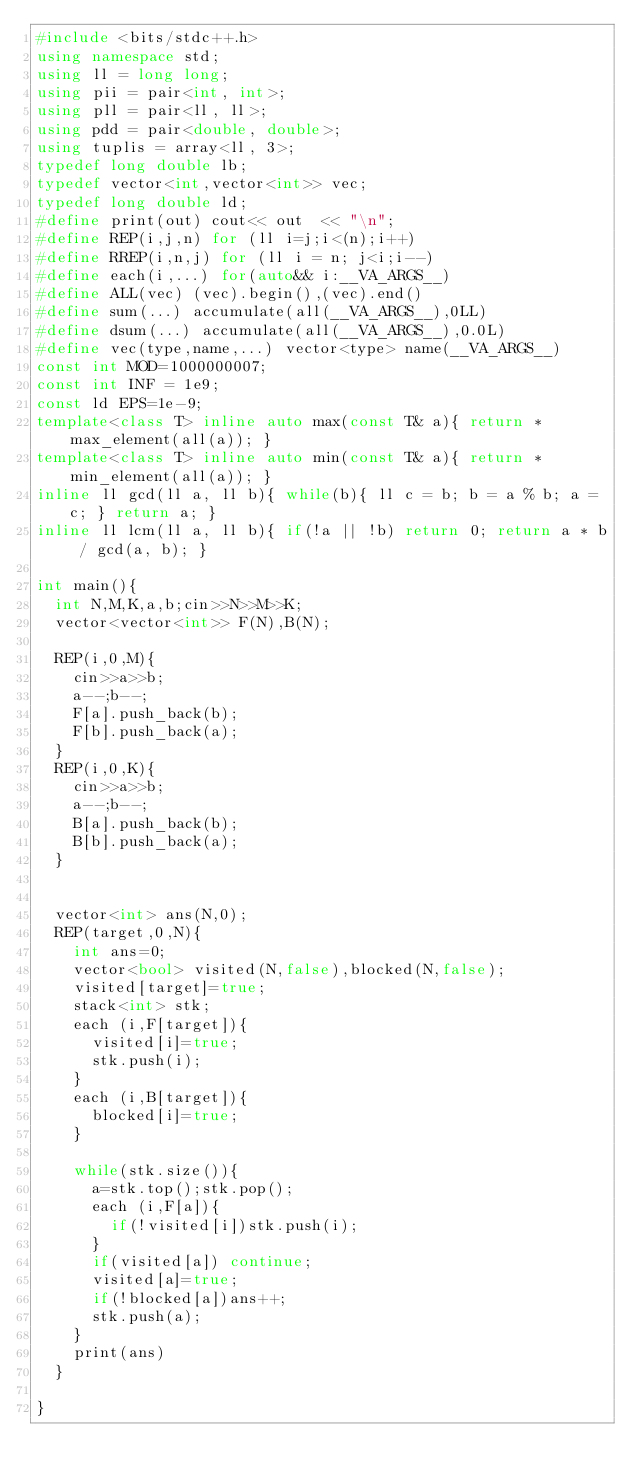<code> <loc_0><loc_0><loc_500><loc_500><_C++_>#include <bits/stdc++.h>
using namespace std;
using ll = long long;
using pii = pair<int, int>;
using pll = pair<ll, ll>;
using pdd = pair<double, double>;
using tuplis = array<ll, 3>;
typedef long double lb;
typedef vector<int,vector<int>> vec;
typedef long double ld;
#define print(out) cout<< out  << "\n";
#define REP(i,j,n) for (ll i=j;i<(n);i++)
#define RREP(i,n,j) for (ll i = n; j<i;i--)
#define each(i,...) for(auto&& i:__VA_ARGS__)
#define ALL(vec) (vec).begin(),(vec).end()
#define sum(...) accumulate(all(__VA_ARGS__),0LL)
#define dsum(...) accumulate(all(__VA_ARGS__),0.0L)
#define vec(type,name,...) vector<type> name(__VA_ARGS__)
const int MOD=1000000007;
const int INF = 1e9;
const ld EPS=1e-9;
template<class T> inline auto max(const T& a){ return *max_element(all(a)); }
template<class T> inline auto min(const T& a){ return *min_element(all(a)); }
inline ll gcd(ll a, ll b){ while(b){ ll c = b; b = a % b; a = c; } return a; }
inline ll lcm(ll a, ll b){ if(!a || !b) return 0; return a * b / gcd(a, b); }

int main(){
  int N,M,K,a,b;cin>>N>>M>>K;
  vector<vector<int>> F(N),B(N);

  REP(i,0,M){
    cin>>a>>b;
    a--;b--;
    F[a].push_back(b);
    F[b].push_back(a);
  }
  REP(i,0,K){
    cin>>a>>b;
    a--;b--;
    B[a].push_back(b);
    B[b].push_back(a);
  }
  

  vector<int> ans(N,0);
  REP(target,0,N){
    int ans=0;
    vector<bool> visited(N,false),blocked(N,false);
    visited[target]=true;
    stack<int> stk;
    each (i,F[target]){
      visited[i]=true;
      stk.push(i);
    }
    each (i,B[target]){
      blocked[i]=true;
    }

    while(stk.size()){
      a=stk.top();stk.pop();
      each (i,F[a]){
        if(!visited[i])stk.push(i);
      }
      if(visited[a]) continue;
      visited[a]=true;
      if(!blocked[a])ans++;
      stk.push(a);
    }
    print(ans)
  }

}
</code> 